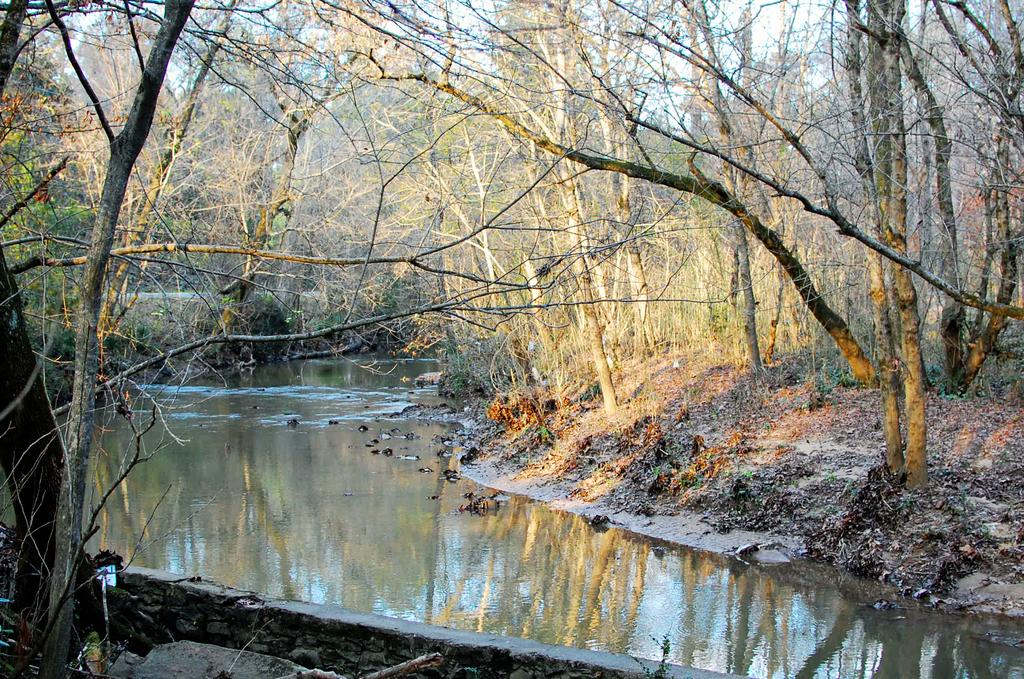What is the main subject in the center of the image? There is water in the center of the image. What can be seen in the background of the image? There are trees in the background of the image. How many noses can be seen in the image? There are no noses present in the image. Are there any flies visible in the image? There are no flies visible in the image. 